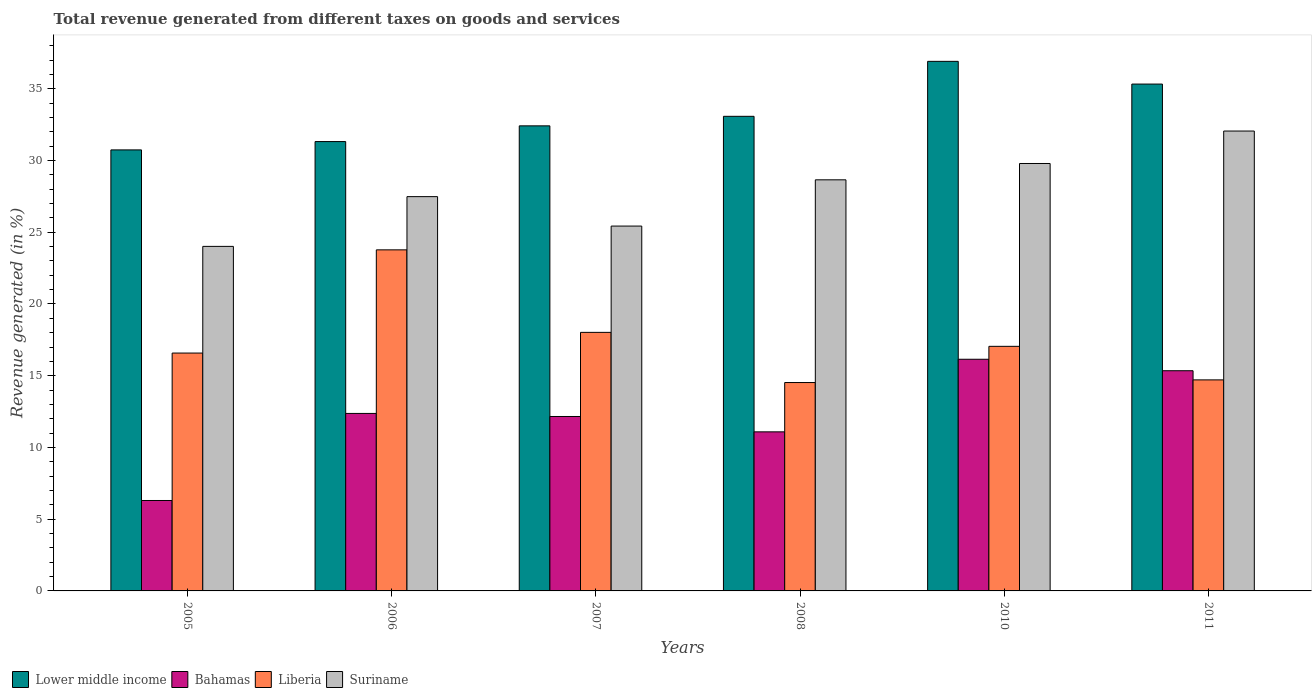How many groups of bars are there?
Provide a succinct answer. 6. How many bars are there on the 2nd tick from the right?
Give a very brief answer. 4. In how many cases, is the number of bars for a given year not equal to the number of legend labels?
Keep it short and to the point. 0. What is the total revenue generated in Suriname in 2010?
Give a very brief answer. 29.79. Across all years, what is the maximum total revenue generated in Liberia?
Provide a short and direct response. 23.77. Across all years, what is the minimum total revenue generated in Suriname?
Give a very brief answer. 24.01. In which year was the total revenue generated in Suriname maximum?
Provide a succinct answer. 2011. In which year was the total revenue generated in Suriname minimum?
Make the answer very short. 2005. What is the total total revenue generated in Liberia in the graph?
Make the answer very short. 104.65. What is the difference between the total revenue generated in Bahamas in 2005 and that in 2010?
Ensure brevity in your answer.  -9.84. What is the difference between the total revenue generated in Suriname in 2007 and the total revenue generated in Liberia in 2011?
Provide a succinct answer. 10.72. What is the average total revenue generated in Suriname per year?
Ensure brevity in your answer.  27.9. In the year 2006, what is the difference between the total revenue generated in Lower middle income and total revenue generated in Suriname?
Offer a terse response. 3.84. What is the ratio of the total revenue generated in Lower middle income in 2005 to that in 2007?
Offer a very short reply. 0.95. Is the total revenue generated in Lower middle income in 2005 less than that in 2008?
Your response must be concise. Yes. What is the difference between the highest and the second highest total revenue generated in Bahamas?
Keep it short and to the point. 0.8. What is the difference between the highest and the lowest total revenue generated in Liberia?
Offer a terse response. 9.25. Is the sum of the total revenue generated in Suriname in 2005 and 2008 greater than the maximum total revenue generated in Bahamas across all years?
Provide a short and direct response. Yes. Is it the case that in every year, the sum of the total revenue generated in Bahamas and total revenue generated in Liberia is greater than the sum of total revenue generated in Lower middle income and total revenue generated in Suriname?
Give a very brief answer. No. What does the 1st bar from the left in 2008 represents?
Offer a terse response. Lower middle income. What does the 2nd bar from the right in 2007 represents?
Give a very brief answer. Liberia. How many bars are there?
Ensure brevity in your answer.  24. Are all the bars in the graph horizontal?
Ensure brevity in your answer.  No. Are the values on the major ticks of Y-axis written in scientific E-notation?
Provide a short and direct response. No. Does the graph contain grids?
Your answer should be very brief. No. Where does the legend appear in the graph?
Offer a very short reply. Bottom left. How many legend labels are there?
Offer a very short reply. 4. What is the title of the graph?
Your answer should be very brief. Total revenue generated from different taxes on goods and services. Does "Yemen, Rep." appear as one of the legend labels in the graph?
Your response must be concise. No. What is the label or title of the X-axis?
Provide a short and direct response. Years. What is the label or title of the Y-axis?
Ensure brevity in your answer.  Revenue generated (in %). What is the Revenue generated (in %) in Lower middle income in 2005?
Your answer should be very brief. 30.74. What is the Revenue generated (in %) in Bahamas in 2005?
Offer a terse response. 6.3. What is the Revenue generated (in %) in Liberia in 2005?
Provide a succinct answer. 16.58. What is the Revenue generated (in %) in Suriname in 2005?
Your answer should be compact. 24.01. What is the Revenue generated (in %) of Lower middle income in 2006?
Keep it short and to the point. 31.32. What is the Revenue generated (in %) in Bahamas in 2006?
Keep it short and to the point. 12.37. What is the Revenue generated (in %) of Liberia in 2006?
Make the answer very short. 23.77. What is the Revenue generated (in %) in Suriname in 2006?
Offer a terse response. 27.48. What is the Revenue generated (in %) in Lower middle income in 2007?
Provide a short and direct response. 32.41. What is the Revenue generated (in %) of Bahamas in 2007?
Give a very brief answer. 12.16. What is the Revenue generated (in %) in Liberia in 2007?
Make the answer very short. 18.02. What is the Revenue generated (in %) in Suriname in 2007?
Your answer should be compact. 25.43. What is the Revenue generated (in %) of Lower middle income in 2008?
Make the answer very short. 33.08. What is the Revenue generated (in %) of Bahamas in 2008?
Offer a very short reply. 11.09. What is the Revenue generated (in %) of Liberia in 2008?
Provide a short and direct response. 14.52. What is the Revenue generated (in %) of Suriname in 2008?
Your answer should be very brief. 28.65. What is the Revenue generated (in %) of Lower middle income in 2010?
Your answer should be compact. 36.91. What is the Revenue generated (in %) in Bahamas in 2010?
Ensure brevity in your answer.  16.15. What is the Revenue generated (in %) in Liberia in 2010?
Give a very brief answer. 17.05. What is the Revenue generated (in %) in Suriname in 2010?
Your answer should be compact. 29.79. What is the Revenue generated (in %) of Lower middle income in 2011?
Your response must be concise. 35.33. What is the Revenue generated (in %) of Bahamas in 2011?
Ensure brevity in your answer.  15.35. What is the Revenue generated (in %) of Liberia in 2011?
Ensure brevity in your answer.  14.71. What is the Revenue generated (in %) in Suriname in 2011?
Give a very brief answer. 32.05. Across all years, what is the maximum Revenue generated (in %) of Lower middle income?
Your answer should be very brief. 36.91. Across all years, what is the maximum Revenue generated (in %) of Bahamas?
Provide a succinct answer. 16.15. Across all years, what is the maximum Revenue generated (in %) of Liberia?
Offer a terse response. 23.77. Across all years, what is the maximum Revenue generated (in %) in Suriname?
Your answer should be compact. 32.05. Across all years, what is the minimum Revenue generated (in %) in Lower middle income?
Make the answer very short. 30.74. Across all years, what is the minimum Revenue generated (in %) of Bahamas?
Offer a very short reply. 6.3. Across all years, what is the minimum Revenue generated (in %) in Liberia?
Your answer should be compact. 14.52. Across all years, what is the minimum Revenue generated (in %) in Suriname?
Your answer should be compact. 24.01. What is the total Revenue generated (in %) in Lower middle income in the graph?
Offer a terse response. 199.78. What is the total Revenue generated (in %) in Bahamas in the graph?
Provide a short and direct response. 73.41. What is the total Revenue generated (in %) in Liberia in the graph?
Give a very brief answer. 104.65. What is the total Revenue generated (in %) of Suriname in the graph?
Your answer should be compact. 167.41. What is the difference between the Revenue generated (in %) in Lower middle income in 2005 and that in 2006?
Provide a short and direct response. -0.58. What is the difference between the Revenue generated (in %) of Bahamas in 2005 and that in 2006?
Your answer should be very brief. -6.07. What is the difference between the Revenue generated (in %) in Liberia in 2005 and that in 2006?
Your answer should be very brief. -7.19. What is the difference between the Revenue generated (in %) in Suriname in 2005 and that in 2006?
Your answer should be very brief. -3.47. What is the difference between the Revenue generated (in %) in Lower middle income in 2005 and that in 2007?
Your answer should be compact. -1.68. What is the difference between the Revenue generated (in %) of Bahamas in 2005 and that in 2007?
Provide a short and direct response. -5.85. What is the difference between the Revenue generated (in %) in Liberia in 2005 and that in 2007?
Provide a succinct answer. -1.44. What is the difference between the Revenue generated (in %) in Suriname in 2005 and that in 2007?
Provide a succinct answer. -1.42. What is the difference between the Revenue generated (in %) in Lower middle income in 2005 and that in 2008?
Your response must be concise. -2.34. What is the difference between the Revenue generated (in %) in Bahamas in 2005 and that in 2008?
Provide a short and direct response. -4.78. What is the difference between the Revenue generated (in %) of Liberia in 2005 and that in 2008?
Provide a short and direct response. 2.06. What is the difference between the Revenue generated (in %) of Suriname in 2005 and that in 2008?
Ensure brevity in your answer.  -4.64. What is the difference between the Revenue generated (in %) of Lower middle income in 2005 and that in 2010?
Your answer should be very brief. -6.17. What is the difference between the Revenue generated (in %) in Bahamas in 2005 and that in 2010?
Offer a very short reply. -9.84. What is the difference between the Revenue generated (in %) of Liberia in 2005 and that in 2010?
Your response must be concise. -0.47. What is the difference between the Revenue generated (in %) in Suriname in 2005 and that in 2010?
Offer a terse response. -5.78. What is the difference between the Revenue generated (in %) in Lower middle income in 2005 and that in 2011?
Your response must be concise. -4.59. What is the difference between the Revenue generated (in %) of Bahamas in 2005 and that in 2011?
Provide a short and direct response. -9.04. What is the difference between the Revenue generated (in %) of Liberia in 2005 and that in 2011?
Offer a very short reply. 1.87. What is the difference between the Revenue generated (in %) of Suriname in 2005 and that in 2011?
Offer a terse response. -8.04. What is the difference between the Revenue generated (in %) of Lower middle income in 2006 and that in 2007?
Offer a very short reply. -1.1. What is the difference between the Revenue generated (in %) of Bahamas in 2006 and that in 2007?
Give a very brief answer. 0.21. What is the difference between the Revenue generated (in %) of Liberia in 2006 and that in 2007?
Make the answer very short. 5.75. What is the difference between the Revenue generated (in %) of Suriname in 2006 and that in 2007?
Provide a short and direct response. 2.05. What is the difference between the Revenue generated (in %) of Lower middle income in 2006 and that in 2008?
Your answer should be compact. -1.76. What is the difference between the Revenue generated (in %) of Bahamas in 2006 and that in 2008?
Your answer should be very brief. 1.28. What is the difference between the Revenue generated (in %) in Liberia in 2006 and that in 2008?
Keep it short and to the point. 9.25. What is the difference between the Revenue generated (in %) of Suriname in 2006 and that in 2008?
Your answer should be very brief. -1.17. What is the difference between the Revenue generated (in %) of Lower middle income in 2006 and that in 2010?
Keep it short and to the point. -5.59. What is the difference between the Revenue generated (in %) in Bahamas in 2006 and that in 2010?
Make the answer very short. -3.78. What is the difference between the Revenue generated (in %) in Liberia in 2006 and that in 2010?
Give a very brief answer. 6.73. What is the difference between the Revenue generated (in %) of Suriname in 2006 and that in 2010?
Provide a short and direct response. -2.31. What is the difference between the Revenue generated (in %) in Lower middle income in 2006 and that in 2011?
Provide a succinct answer. -4.01. What is the difference between the Revenue generated (in %) in Bahamas in 2006 and that in 2011?
Provide a short and direct response. -2.98. What is the difference between the Revenue generated (in %) in Liberia in 2006 and that in 2011?
Keep it short and to the point. 9.06. What is the difference between the Revenue generated (in %) of Suriname in 2006 and that in 2011?
Provide a short and direct response. -4.57. What is the difference between the Revenue generated (in %) of Lower middle income in 2007 and that in 2008?
Offer a terse response. -0.66. What is the difference between the Revenue generated (in %) of Bahamas in 2007 and that in 2008?
Your answer should be very brief. 1.07. What is the difference between the Revenue generated (in %) in Liberia in 2007 and that in 2008?
Your answer should be very brief. 3.5. What is the difference between the Revenue generated (in %) in Suriname in 2007 and that in 2008?
Your response must be concise. -3.22. What is the difference between the Revenue generated (in %) of Lower middle income in 2007 and that in 2010?
Your answer should be compact. -4.5. What is the difference between the Revenue generated (in %) of Bahamas in 2007 and that in 2010?
Give a very brief answer. -3.99. What is the difference between the Revenue generated (in %) of Liberia in 2007 and that in 2010?
Make the answer very short. 0.97. What is the difference between the Revenue generated (in %) in Suriname in 2007 and that in 2010?
Offer a terse response. -4.36. What is the difference between the Revenue generated (in %) in Lower middle income in 2007 and that in 2011?
Make the answer very short. -2.91. What is the difference between the Revenue generated (in %) in Bahamas in 2007 and that in 2011?
Provide a short and direct response. -3.19. What is the difference between the Revenue generated (in %) in Liberia in 2007 and that in 2011?
Offer a very short reply. 3.31. What is the difference between the Revenue generated (in %) of Suriname in 2007 and that in 2011?
Your answer should be compact. -6.62. What is the difference between the Revenue generated (in %) of Lower middle income in 2008 and that in 2010?
Your response must be concise. -3.83. What is the difference between the Revenue generated (in %) of Bahamas in 2008 and that in 2010?
Your answer should be very brief. -5.06. What is the difference between the Revenue generated (in %) of Liberia in 2008 and that in 2010?
Ensure brevity in your answer.  -2.52. What is the difference between the Revenue generated (in %) in Suriname in 2008 and that in 2010?
Provide a short and direct response. -1.14. What is the difference between the Revenue generated (in %) of Lower middle income in 2008 and that in 2011?
Provide a short and direct response. -2.25. What is the difference between the Revenue generated (in %) of Bahamas in 2008 and that in 2011?
Offer a very short reply. -4.26. What is the difference between the Revenue generated (in %) in Liberia in 2008 and that in 2011?
Offer a terse response. -0.19. What is the difference between the Revenue generated (in %) of Suriname in 2008 and that in 2011?
Give a very brief answer. -3.4. What is the difference between the Revenue generated (in %) of Lower middle income in 2010 and that in 2011?
Your answer should be very brief. 1.58. What is the difference between the Revenue generated (in %) in Bahamas in 2010 and that in 2011?
Your response must be concise. 0.8. What is the difference between the Revenue generated (in %) in Liberia in 2010 and that in 2011?
Provide a succinct answer. 2.34. What is the difference between the Revenue generated (in %) in Suriname in 2010 and that in 2011?
Ensure brevity in your answer.  -2.26. What is the difference between the Revenue generated (in %) in Lower middle income in 2005 and the Revenue generated (in %) in Bahamas in 2006?
Your response must be concise. 18.37. What is the difference between the Revenue generated (in %) of Lower middle income in 2005 and the Revenue generated (in %) of Liberia in 2006?
Your response must be concise. 6.97. What is the difference between the Revenue generated (in %) of Lower middle income in 2005 and the Revenue generated (in %) of Suriname in 2006?
Your answer should be compact. 3.26. What is the difference between the Revenue generated (in %) in Bahamas in 2005 and the Revenue generated (in %) in Liberia in 2006?
Make the answer very short. -17.47. What is the difference between the Revenue generated (in %) of Bahamas in 2005 and the Revenue generated (in %) of Suriname in 2006?
Ensure brevity in your answer.  -21.18. What is the difference between the Revenue generated (in %) of Liberia in 2005 and the Revenue generated (in %) of Suriname in 2006?
Your response must be concise. -10.9. What is the difference between the Revenue generated (in %) of Lower middle income in 2005 and the Revenue generated (in %) of Bahamas in 2007?
Keep it short and to the point. 18.58. What is the difference between the Revenue generated (in %) in Lower middle income in 2005 and the Revenue generated (in %) in Liberia in 2007?
Keep it short and to the point. 12.72. What is the difference between the Revenue generated (in %) of Lower middle income in 2005 and the Revenue generated (in %) of Suriname in 2007?
Keep it short and to the point. 5.31. What is the difference between the Revenue generated (in %) of Bahamas in 2005 and the Revenue generated (in %) of Liberia in 2007?
Make the answer very short. -11.72. What is the difference between the Revenue generated (in %) of Bahamas in 2005 and the Revenue generated (in %) of Suriname in 2007?
Offer a very short reply. -19.13. What is the difference between the Revenue generated (in %) in Liberia in 2005 and the Revenue generated (in %) in Suriname in 2007?
Your answer should be compact. -8.85. What is the difference between the Revenue generated (in %) of Lower middle income in 2005 and the Revenue generated (in %) of Bahamas in 2008?
Provide a succinct answer. 19.65. What is the difference between the Revenue generated (in %) of Lower middle income in 2005 and the Revenue generated (in %) of Liberia in 2008?
Your answer should be very brief. 16.21. What is the difference between the Revenue generated (in %) in Lower middle income in 2005 and the Revenue generated (in %) in Suriname in 2008?
Ensure brevity in your answer.  2.09. What is the difference between the Revenue generated (in %) of Bahamas in 2005 and the Revenue generated (in %) of Liberia in 2008?
Make the answer very short. -8.22. What is the difference between the Revenue generated (in %) in Bahamas in 2005 and the Revenue generated (in %) in Suriname in 2008?
Your answer should be very brief. -22.35. What is the difference between the Revenue generated (in %) of Liberia in 2005 and the Revenue generated (in %) of Suriname in 2008?
Offer a very short reply. -12.07. What is the difference between the Revenue generated (in %) of Lower middle income in 2005 and the Revenue generated (in %) of Bahamas in 2010?
Offer a very short reply. 14.59. What is the difference between the Revenue generated (in %) of Lower middle income in 2005 and the Revenue generated (in %) of Liberia in 2010?
Your answer should be compact. 13.69. What is the difference between the Revenue generated (in %) in Lower middle income in 2005 and the Revenue generated (in %) in Suriname in 2010?
Your answer should be very brief. 0.95. What is the difference between the Revenue generated (in %) in Bahamas in 2005 and the Revenue generated (in %) in Liberia in 2010?
Offer a terse response. -10.74. What is the difference between the Revenue generated (in %) of Bahamas in 2005 and the Revenue generated (in %) of Suriname in 2010?
Your answer should be very brief. -23.49. What is the difference between the Revenue generated (in %) in Liberia in 2005 and the Revenue generated (in %) in Suriname in 2010?
Give a very brief answer. -13.21. What is the difference between the Revenue generated (in %) in Lower middle income in 2005 and the Revenue generated (in %) in Bahamas in 2011?
Your answer should be compact. 15.39. What is the difference between the Revenue generated (in %) in Lower middle income in 2005 and the Revenue generated (in %) in Liberia in 2011?
Keep it short and to the point. 16.03. What is the difference between the Revenue generated (in %) in Lower middle income in 2005 and the Revenue generated (in %) in Suriname in 2011?
Your answer should be very brief. -1.32. What is the difference between the Revenue generated (in %) in Bahamas in 2005 and the Revenue generated (in %) in Liberia in 2011?
Make the answer very short. -8.41. What is the difference between the Revenue generated (in %) in Bahamas in 2005 and the Revenue generated (in %) in Suriname in 2011?
Your answer should be very brief. -25.75. What is the difference between the Revenue generated (in %) of Liberia in 2005 and the Revenue generated (in %) of Suriname in 2011?
Keep it short and to the point. -15.47. What is the difference between the Revenue generated (in %) of Lower middle income in 2006 and the Revenue generated (in %) of Bahamas in 2007?
Offer a very short reply. 19.16. What is the difference between the Revenue generated (in %) of Lower middle income in 2006 and the Revenue generated (in %) of Liberia in 2007?
Provide a succinct answer. 13.3. What is the difference between the Revenue generated (in %) of Lower middle income in 2006 and the Revenue generated (in %) of Suriname in 2007?
Your answer should be very brief. 5.89. What is the difference between the Revenue generated (in %) of Bahamas in 2006 and the Revenue generated (in %) of Liberia in 2007?
Ensure brevity in your answer.  -5.65. What is the difference between the Revenue generated (in %) in Bahamas in 2006 and the Revenue generated (in %) in Suriname in 2007?
Ensure brevity in your answer.  -13.06. What is the difference between the Revenue generated (in %) in Liberia in 2006 and the Revenue generated (in %) in Suriname in 2007?
Your answer should be very brief. -1.66. What is the difference between the Revenue generated (in %) of Lower middle income in 2006 and the Revenue generated (in %) of Bahamas in 2008?
Make the answer very short. 20.23. What is the difference between the Revenue generated (in %) in Lower middle income in 2006 and the Revenue generated (in %) in Liberia in 2008?
Provide a succinct answer. 16.79. What is the difference between the Revenue generated (in %) in Lower middle income in 2006 and the Revenue generated (in %) in Suriname in 2008?
Ensure brevity in your answer.  2.67. What is the difference between the Revenue generated (in %) in Bahamas in 2006 and the Revenue generated (in %) in Liberia in 2008?
Ensure brevity in your answer.  -2.15. What is the difference between the Revenue generated (in %) of Bahamas in 2006 and the Revenue generated (in %) of Suriname in 2008?
Your response must be concise. -16.28. What is the difference between the Revenue generated (in %) in Liberia in 2006 and the Revenue generated (in %) in Suriname in 2008?
Your answer should be very brief. -4.88. What is the difference between the Revenue generated (in %) in Lower middle income in 2006 and the Revenue generated (in %) in Bahamas in 2010?
Ensure brevity in your answer.  15.17. What is the difference between the Revenue generated (in %) in Lower middle income in 2006 and the Revenue generated (in %) in Liberia in 2010?
Keep it short and to the point. 14.27. What is the difference between the Revenue generated (in %) of Lower middle income in 2006 and the Revenue generated (in %) of Suriname in 2010?
Your answer should be compact. 1.53. What is the difference between the Revenue generated (in %) in Bahamas in 2006 and the Revenue generated (in %) in Liberia in 2010?
Offer a very short reply. -4.68. What is the difference between the Revenue generated (in %) in Bahamas in 2006 and the Revenue generated (in %) in Suriname in 2010?
Make the answer very short. -17.42. What is the difference between the Revenue generated (in %) in Liberia in 2006 and the Revenue generated (in %) in Suriname in 2010?
Offer a very short reply. -6.02. What is the difference between the Revenue generated (in %) of Lower middle income in 2006 and the Revenue generated (in %) of Bahamas in 2011?
Your answer should be very brief. 15.97. What is the difference between the Revenue generated (in %) in Lower middle income in 2006 and the Revenue generated (in %) in Liberia in 2011?
Your answer should be compact. 16.61. What is the difference between the Revenue generated (in %) in Lower middle income in 2006 and the Revenue generated (in %) in Suriname in 2011?
Keep it short and to the point. -0.73. What is the difference between the Revenue generated (in %) of Bahamas in 2006 and the Revenue generated (in %) of Liberia in 2011?
Your answer should be very brief. -2.34. What is the difference between the Revenue generated (in %) of Bahamas in 2006 and the Revenue generated (in %) of Suriname in 2011?
Offer a terse response. -19.68. What is the difference between the Revenue generated (in %) in Liberia in 2006 and the Revenue generated (in %) in Suriname in 2011?
Provide a short and direct response. -8.28. What is the difference between the Revenue generated (in %) of Lower middle income in 2007 and the Revenue generated (in %) of Bahamas in 2008?
Make the answer very short. 21.33. What is the difference between the Revenue generated (in %) of Lower middle income in 2007 and the Revenue generated (in %) of Liberia in 2008?
Make the answer very short. 17.89. What is the difference between the Revenue generated (in %) of Lower middle income in 2007 and the Revenue generated (in %) of Suriname in 2008?
Ensure brevity in your answer.  3.76. What is the difference between the Revenue generated (in %) of Bahamas in 2007 and the Revenue generated (in %) of Liberia in 2008?
Make the answer very short. -2.37. What is the difference between the Revenue generated (in %) of Bahamas in 2007 and the Revenue generated (in %) of Suriname in 2008?
Your response must be concise. -16.5. What is the difference between the Revenue generated (in %) in Liberia in 2007 and the Revenue generated (in %) in Suriname in 2008?
Offer a very short reply. -10.63. What is the difference between the Revenue generated (in %) of Lower middle income in 2007 and the Revenue generated (in %) of Bahamas in 2010?
Give a very brief answer. 16.27. What is the difference between the Revenue generated (in %) of Lower middle income in 2007 and the Revenue generated (in %) of Liberia in 2010?
Give a very brief answer. 15.37. What is the difference between the Revenue generated (in %) in Lower middle income in 2007 and the Revenue generated (in %) in Suriname in 2010?
Provide a short and direct response. 2.62. What is the difference between the Revenue generated (in %) of Bahamas in 2007 and the Revenue generated (in %) of Liberia in 2010?
Offer a very short reply. -4.89. What is the difference between the Revenue generated (in %) in Bahamas in 2007 and the Revenue generated (in %) in Suriname in 2010?
Your answer should be compact. -17.63. What is the difference between the Revenue generated (in %) in Liberia in 2007 and the Revenue generated (in %) in Suriname in 2010?
Offer a very short reply. -11.77. What is the difference between the Revenue generated (in %) in Lower middle income in 2007 and the Revenue generated (in %) in Bahamas in 2011?
Provide a short and direct response. 17.07. What is the difference between the Revenue generated (in %) of Lower middle income in 2007 and the Revenue generated (in %) of Liberia in 2011?
Offer a terse response. 17.71. What is the difference between the Revenue generated (in %) of Lower middle income in 2007 and the Revenue generated (in %) of Suriname in 2011?
Ensure brevity in your answer.  0.36. What is the difference between the Revenue generated (in %) of Bahamas in 2007 and the Revenue generated (in %) of Liberia in 2011?
Provide a short and direct response. -2.55. What is the difference between the Revenue generated (in %) of Bahamas in 2007 and the Revenue generated (in %) of Suriname in 2011?
Make the answer very short. -19.9. What is the difference between the Revenue generated (in %) in Liberia in 2007 and the Revenue generated (in %) in Suriname in 2011?
Give a very brief answer. -14.03. What is the difference between the Revenue generated (in %) of Lower middle income in 2008 and the Revenue generated (in %) of Bahamas in 2010?
Keep it short and to the point. 16.93. What is the difference between the Revenue generated (in %) of Lower middle income in 2008 and the Revenue generated (in %) of Liberia in 2010?
Your response must be concise. 16.03. What is the difference between the Revenue generated (in %) in Lower middle income in 2008 and the Revenue generated (in %) in Suriname in 2010?
Your answer should be compact. 3.29. What is the difference between the Revenue generated (in %) of Bahamas in 2008 and the Revenue generated (in %) of Liberia in 2010?
Provide a succinct answer. -5.96. What is the difference between the Revenue generated (in %) in Bahamas in 2008 and the Revenue generated (in %) in Suriname in 2010?
Ensure brevity in your answer.  -18.7. What is the difference between the Revenue generated (in %) of Liberia in 2008 and the Revenue generated (in %) of Suriname in 2010?
Your answer should be very brief. -15.27. What is the difference between the Revenue generated (in %) in Lower middle income in 2008 and the Revenue generated (in %) in Bahamas in 2011?
Your response must be concise. 17.73. What is the difference between the Revenue generated (in %) in Lower middle income in 2008 and the Revenue generated (in %) in Liberia in 2011?
Ensure brevity in your answer.  18.37. What is the difference between the Revenue generated (in %) of Lower middle income in 2008 and the Revenue generated (in %) of Suriname in 2011?
Offer a very short reply. 1.03. What is the difference between the Revenue generated (in %) in Bahamas in 2008 and the Revenue generated (in %) in Liberia in 2011?
Give a very brief answer. -3.62. What is the difference between the Revenue generated (in %) of Bahamas in 2008 and the Revenue generated (in %) of Suriname in 2011?
Keep it short and to the point. -20.97. What is the difference between the Revenue generated (in %) of Liberia in 2008 and the Revenue generated (in %) of Suriname in 2011?
Provide a short and direct response. -17.53. What is the difference between the Revenue generated (in %) of Lower middle income in 2010 and the Revenue generated (in %) of Bahamas in 2011?
Keep it short and to the point. 21.56. What is the difference between the Revenue generated (in %) in Lower middle income in 2010 and the Revenue generated (in %) in Liberia in 2011?
Keep it short and to the point. 22.2. What is the difference between the Revenue generated (in %) of Lower middle income in 2010 and the Revenue generated (in %) of Suriname in 2011?
Your answer should be compact. 4.86. What is the difference between the Revenue generated (in %) in Bahamas in 2010 and the Revenue generated (in %) in Liberia in 2011?
Provide a short and direct response. 1.44. What is the difference between the Revenue generated (in %) of Bahamas in 2010 and the Revenue generated (in %) of Suriname in 2011?
Your answer should be very brief. -15.91. What is the difference between the Revenue generated (in %) of Liberia in 2010 and the Revenue generated (in %) of Suriname in 2011?
Your answer should be compact. -15.01. What is the average Revenue generated (in %) in Lower middle income per year?
Provide a succinct answer. 33.3. What is the average Revenue generated (in %) of Bahamas per year?
Your response must be concise. 12.23. What is the average Revenue generated (in %) in Liberia per year?
Provide a short and direct response. 17.44. What is the average Revenue generated (in %) of Suriname per year?
Offer a terse response. 27.9. In the year 2005, what is the difference between the Revenue generated (in %) in Lower middle income and Revenue generated (in %) in Bahamas?
Ensure brevity in your answer.  24.43. In the year 2005, what is the difference between the Revenue generated (in %) of Lower middle income and Revenue generated (in %) of Liberia?
Your answer should be very brief. 14.16. In the year 2005, what is the difference between the Revenue generated (in %) of Lower middle income and Revenue generated (in %) of Suriname?
Provide a short and direct response. 6.72. In the year 2005, what is the difference between the Revenue generated (in %) in Bahamas and Revenue generated (in %) in Liberia?
Provide a short and direct response. -10.28. In the year 2005, what is the difference between the Revenue generated (in %) of Bahamas and Revenue generated (in %) of Suriname?
Ensure brevity in your answer.  -17.71. In the year 2005, what is the difference between the Revenue generated (in %) of Liberia and Revenue generated (in %) of Suriname?
Offer a very short reply. -7.43. In the year 2006, what is the difference between the Revenue generated (in %) in Lower middle income and Revenue generated (in %) in Bahamas?
Provide a succinct answer. 18.95. In the year 2006, what is the difference between the Revenue generated (in %) of Lower middle income and Revenue generated (in %) of Liberia?
Ensure brevity in your answer.  7.55. In the year 2006, what is the difference between the Revenue generated (in %) in Lower middle income and Revenue generated (in %) in Suriname?
Provide a succinct answer. 3.84. In the year 2006, what is the difference between the Revenue generated (in %) of Bahamas and Revenue generated (in %) of Liberia?
Provide a short and direct response. -11.4. In the year 2006, what is the difference between the Revenue generated (in %) of Bahamas and Revenue generated (in %) of Suriname?
Keep it short and to the point. -15.11. In the year 2006, what is the difference between the Revenue generated (in %) in Liberia and Revenue generated (in %) in Suriname?
Provide a short and direct response. -3.71. In the year 2007, what is the difference between the Revenue generated (in %) of Lower middle income and Revenue generated (in %) of Bahamas?
Give a very brief answer. 20.26. In the year 2007, what is the difference between the Revenue generated (in %) of Lower middle income and Revenue generated (in %) of Liberia?
Provide a short and direct response. 14.39. In the year 2007, what is the difference between the Revenue generated (in %) in Lower middle income and Revenue generated (in %) in Suriname?
Offer a terse response. 6.99. In the year 2007, what is the difference between the Revenue generated (in %) of Bahamas and Revenue generated (in %) of Liberia?
Make the answer very short. -5.86. In the year 2007, what is the difference between the Revenue generated (in %) in Bahamas and Revenue generated (in %) in Suriname?
Keep it short and to the point. -13.27. In the year 2007, what is the difference between the Revenue generated (in %) of Liberia and Revenue generated (in %) of Suriname?
Give a very brief answer. -7.41. In the year 2008, what is the difference between the Revenue generated (in %) of Lower middle income and Revenue generated (in %) of Bahamas?
Provide a succinct answer. 21.99. In the year 2008, what is the difference between the Revenue generated (in %) of Lower middle income and Revenue generated (in %) of Liberia?
Your answer should be very brief. 18.55. In the year 2008, what is the difference between the Revenue generated (in %) in Lower middle income and Revenue generated (in %) in Suriname?
Your answer should be very brief. 4.43. In the year 2008, what is the difference between the Revenue generated (in %) of Bahamas and Revenue generated (in %) of Liberia?
Offer a terse response. -3.44. In the year 2008, what is the difference between the Revenue generated (in %) in Bahamas and Revenue generated (in %) in Suriname?
Make the answer very short. -17.56. In the year 2008, what is the difference between the Revenue generated (in %) of Liberia and Revenue generated (in %) of Suriname?
Offer a terse response. -14.13. In the year 2010, what is the difference between the Revenue generated (in %) of Lower middle income and Revenue generated (in %) of Bahamas?
Your answer should be very brief. 20.76. In the year 2010, what is the difference between the Revenue generated (in %) in Lower middle income and Revenue generated (in %) in Liberia?
Provide a succinct answer. 19.86. In the year 2010, what is the difference between the Revenue generated (in %) of Lower middle income and Revenue generated (in %) of Suriname?
Offer a very short reply. 7.12. In the year 2010, what is the difference between the Revenue generated (in %) in Bahamas and Revenue generated (in %) in Liberia?
Your answer should be compact. -0.9. In the year 2010, what is the difference between the Revenue generated (in %) in Bahamas and Revenue generated (in %) in Suriname?
Offer a terse response. -13.64. In the year 2010, what is the difference between the Revenue generated (in %) in Liberia and Revenue generated (in %) in Suriname?
Provide a succinct answer. -12.74. In the year 2011, what is the difference between the Revenue generated (in %) in Lower middle income and Revenue generated (in %) in Bahamas?
Offer a terse response. 19.98. In the year 2011, what is the difference between the Revenue generated (in %) of Lower middle income and Revenue generated (in %) of Liberia?
Your answer should be compact. 20.62. In the year 2011, what is the difference between the Revenue generated (in %) of Lower middle income and Revenue generated (in %) of Suriname?
Give a very brief answer. 3.27. In the year 2011, what is the difference between the Revenue generated (in %) in Bahamas and Revenue generated (in %) in Liberia?
Offer a terse response. 0.64. In the year 2011, what is the difference between the Revenue generated (in %) of Bahamas and Revenue generated (in %) of Suriname?
Your answer should be very brief. -16.71. In the year 2011, what is the difference between the Revenue generated (in %) of Liberia and Revenue generated (in %) of Suriname?
Make the answer very short. -17.34. What is the ratio of the Revenue generated (in %) of Lower middle income in 2005 to that in 2006?
Your answer should be very brief. 0.98. What is the ratio of the Revenue generated (in %) in Bahamas in 2005 to that in 2006?
Offer a very short reply. 0.51. What is the ratio of the Revenue generated (in %) in Liberia in 2005 to that in 2006?
Provide a short and direct response. 0.7. What is the ratio of the Revenue generated (in %) in Suriname in 2005 to that in 2006?
Ensure brevity in your answer.  0.87. What is the ratio of the Revenue generated (in %) of Lower middle income in 2005 to that in 2007?
Offer a terse response. 0.95. What is the ratio of the Revenue generated (in %) of Bahamas in 2005 to that in 2007?
Provide a short and direct response. 0.52. What is the ratio of the Revenue generated (in %) in Suriname in 2005 to that in 2007?
Give a very brief answer. 0.94. What is the ratio of the Revenue generated (in %) of Lower middle income in 2005 to that in 2008?
Make the answer very short. 0.93. What is the ratio of the Revenue generated (in %) of Bahamas in 2005 to that in 2008?
Your response must be concise. 0.57. What is the ratio of the Revenue generated (in %) in Liberia in 2005 to that in 2008?
Offer a terse response. 1.14. What is the ratio of the Revenue generated (in %) of Suriname in 2005 to that in 2008?
Your response must be concise. 0.84. What is the ratio of the Revenue generated (in %) in Lower middle income in 2005 to that in 2010?
Offer a terse response. 0.83. What is the ratio of the Revenue generated (in %) in Bahamas in 2005 to that in 2010?
Offer a terse response. 0.39. What is the ratio of the Revenue generated (in %) of Liberia in 2005 to that in 2010?
Offer a very short reply. 0.97. What is the ratio of the Revenue generated (in %) in Suriname in 2005 to that in 2010?
Your answer should be very brief. 0.81. What is the ratio of the Revenue generated (in %) of Lower middle income in 2005 to that in 2011?
Make the answer very short. 0.87. What is the ratio of the Revenue generated (in %) in Bahamas in 2005 to that in 2011?
Provide a succinct answer. 0.41. What is the ratio of the Revenue generated (in %) of Liberia in 2005 to that in 2011?
Offer a very short reply. 1.13. What is the ratio of the Revenue generated (in %) of Suriname in 2005 to that in 2011?
Your answer should be very brief. 0.75. What is the ratio of the Revenue generated (in %) of Lower middle income in 2006 to that in 2007?
Offer a very short reply. 0.97. What is the ratio of the Revenue generated (in %) in Bahamas in 2006 to that in 2007?
Your response must be concise. 1.02. What is the ratio of the Revenue generated (in %) in Liberia in 2006 to that in 2007?
Ensure brevity in your answer.  1.32. What is the ratio of the Revenue generated (in %) of Suriname in 2006 to that in 2007?
Provide a short and direct response. 1.08. What is the ratio of the Revenue generated (in %) in Lower middle income in 2006 to that in 2008?
Your answer should be very brief. 0.95. What is the ratio of the Revenue generated (in %) in Bahamas in 2006 to that in 2008?
Your answer should be compact. 1.12. What is the ratio of the Revenue generated (in %) of Liberia in 2006 to that in 2008?
Offer a terse response. 1.64. What is the ratio of the Revenue generated (in %) of Suriname in 2006 to that in 2008?
Ensure brevity in your answer.  0.96. What is the ratio of the Revenue generated (in %) in Lower middle income in 2006 to that in 2010?
Your answer should be compact. 0.85. What is the ratio of the Revenue generated (in %) of Bahamas in 2006 to that in 2010?
Provide a short and direct response. 0.77. What is the ratio of the Revenue generated (in %) of Liberia in 2006 to that in 2010?
Offer a very short reply. 1.39. What is the ratio of the Revenue generated (in %) of Suriname in 2006 to that in 2010?
Your response must be concise. 0.92. What is the ratio of the Revenue generated (in %) in Lower middle income in 2006 to that in 2011?
Offer a very short reply. 0.89. What is the ratio of the Revenue generated (in %) in Bahamas in 2006 to that in 2011?
Keep it short and to the point. 0.81. What is the ratio of the Revenue generated (in %) in Liberia in 2006 to that in 2011?
Your answer should be very brief. 1.62. What is the ratio of the Revenue generated (in %) of Suriname in 2006 to that in 2011?
Keep it short and to the point. 0.86. What is the ratio of the Revenue generated (in %) in Lower middle income in 2007 to that in 2008?
Offer a terse response. 0.98. What is the ratio of the Revenue generated (in %) in Bahamas in 2007 to that in 2008?
Make the answer very short. 1.1. What is the ratio of the Revenue generated (in %) of Liberia in 2007 to that in 2008?
Your response must be concise. 1.24. What is the ratio of the Revenue generated (in %) in Suriname in 2007 to that in 2008?
Give a very brief answer. 0.89. What is the ratio of the Revenue generated (in %) in Lower middle income in 2007 to that in 2010?
Provide a short and direct response. 0.88. What is the ratio of the Revenue generated (in %) of Bahamas in 2007 to that in 2010?
Your answer should be compact. 0.75. What is the ratio of the Revenue generated (in %) of Liberia in 2007 to that in 2010?
Provide a short and direct response. 1.06. What is the ratio of the Revenue generated (in %) of Suriname in 2007 to that in 2010?
Your response must be concise. 0.85. What is the ratio of the Revenue generated (in %) of Lower middle income in 2007 to that in 2011?
Keep it short and to the point. 0.92. What is the ratio of the Revenue generated (in %) of Bahamas in 2007 to that in 2011?
Give a very brief answer. 0.79. What is the ratio of the Revenue generated (in %) of Liberia in 2007 to that in 2011?
Offer a very short reply. 1.23. What is the ratio of the Revenue generated (in %) in Suriname in 2007 to that in 2011?
Make the answer very short. 0.79. What is the ratio of the Revenue generated (in %) in Lower middle income in 2008 to that in 2010?
Give a very brief answer. 0.9. What is the ratio of the Revenue generated (in %) of Bahamas in 2008 to that in 2010?
Your answer should be very brief. 0.69. What is the ratio of the Revenue generated (in %) of Liberia in 2008 to that in 2010?
Keep it short and to the point. 0.85. What is the ratio of the Revenue generated (in %) in Suriname in 2008 to that in 2010?
Provide a succinct answer. 0.96. What is the ratio of the Revenue generated (in %) in Lower middle income in 2008 to that in 2011?
Provide a short and direct response. 0.94. What is the ratio of the Revenue generated (in %) of Bahamas in 2008 to that in 2011?
Offer a very short reply. 0.72. What is the ratio of the Revenue generated (in %) of Liberia in 2008 to that in 2011?
Provide a succinct answer. 0.99. What is the ratio of the Revenue generated (in %) in Suriname in 2008 to that in 2011?
Make the answer very short. 0.89. What is the ratio of the Revenue generated (in %) of Lower middle income in 2010 to that in 2011?
Provide a succinct answer. 1.04. What is the ratio of the Revenue generated (in %) of Bahamas in 2010 to that in 2011?
Provide a short and direct response. 1.05. What is the ratio of the Revenue generated (in %) in Liberia in 2010 to that in 2011?
Keep it short and to the point. 1.16. What is the ratio of the Revenue generated (in %) in Suriname in 2010 to that in 2011?
Offer a very short reply. 0.93. What is the difference between the highest and the second highest Revenue generated (in %) of Lower middle income?
Offer a terse response. 1.58. What is the difference between the highest and the second highest Revenue generated (in %) in Bahamas?
Your answer should be very brief. 0.8. What is the difference between the highest and the second highest Revenue generated (in %) of Liberia?
Provide a short and direct response. 5.75. What is the difference between the highest and the second highest Revenue generated (in %) in Suriname?
Make the answer very short. 2.26. What is the difference between the highest and the lowest Revenue generated (in %) of Lower middle income?
Provide a succinct answer. 6.17. What is the difference between the highest and the lowest Revenue generated (in %) of Bahamas?
Give a very brief answer. 9.84. What is the difference between the highest and the lowest Revenue generated (in %) in Liberia?
Offer a terse response. 9.25. What is the difference between the highest and the lowest Revenue generated (in %) of Suriname?
Keep it short and to the point. 8.04. 